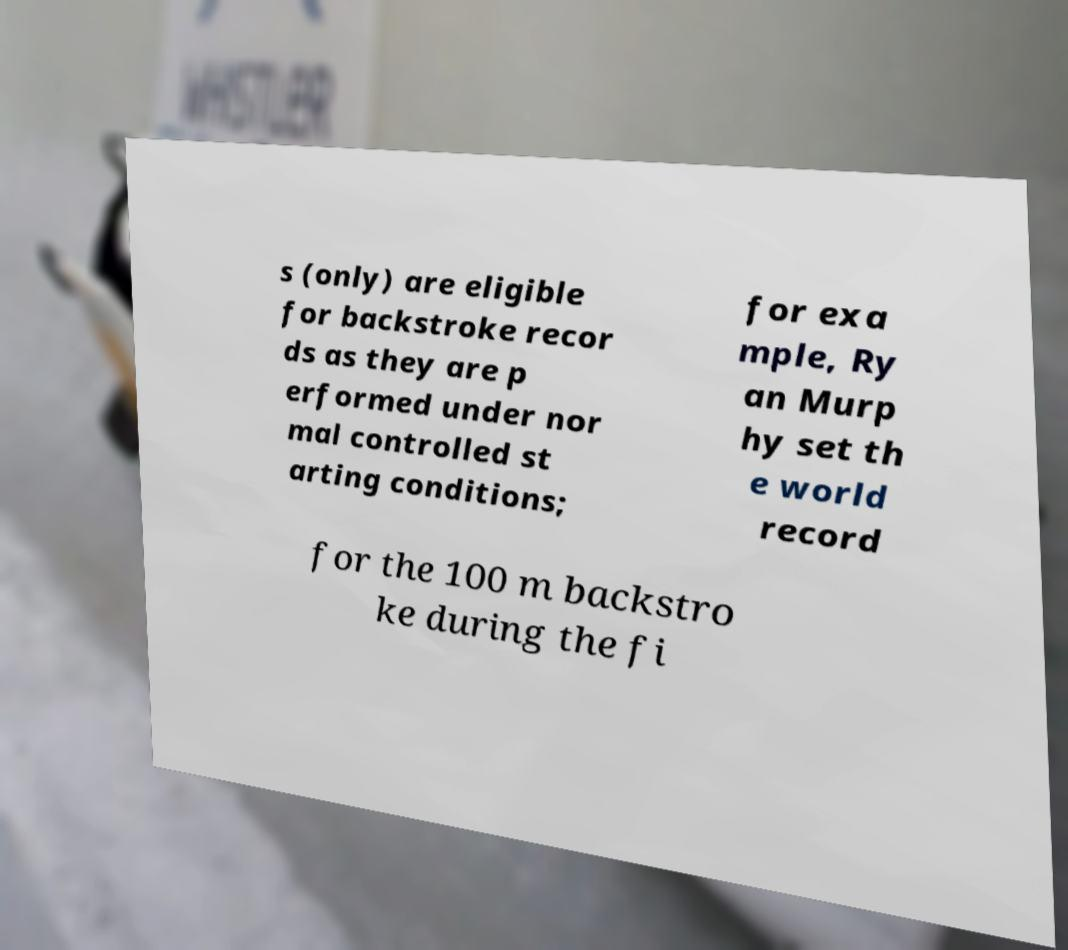For documentation purposes, I need the text within this image transcribed. Could you provide that? s (only) are eligible for backstroke recor ds as they are p erformed under nor mal controlled st arting conditions; for exa mple, Ry an Murp hy set th e world record for the 100 m backstro ke during the fi 